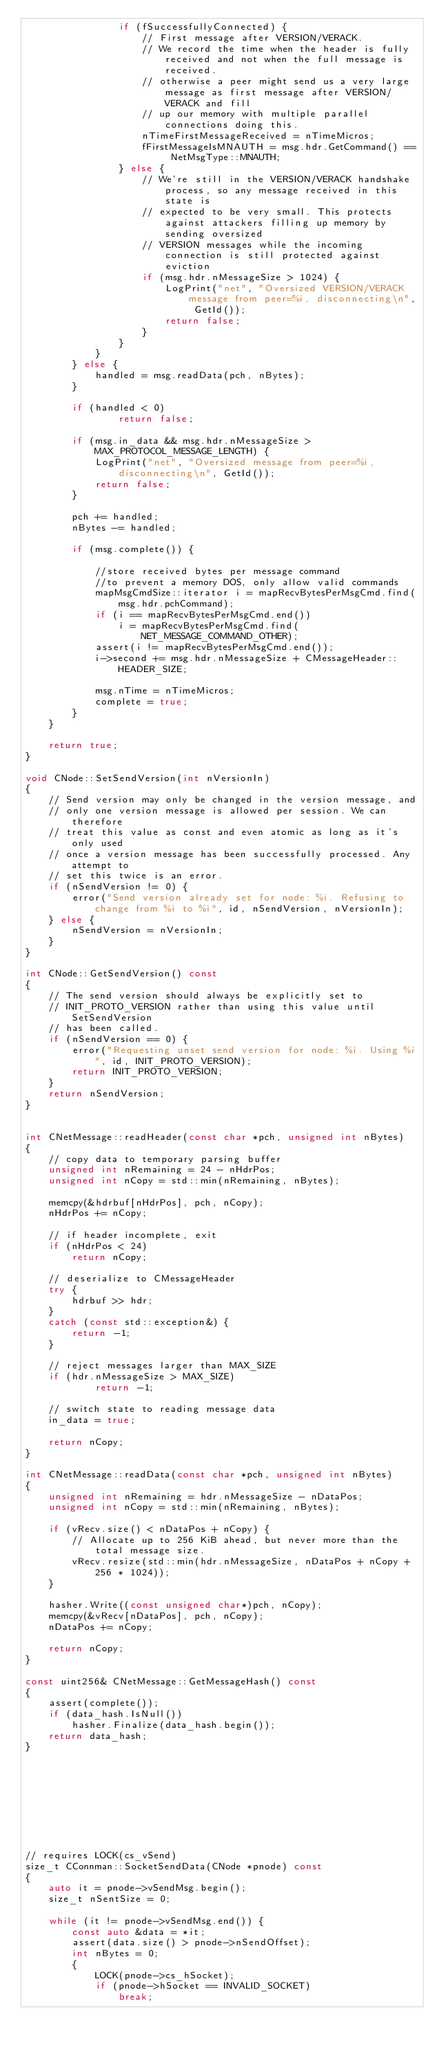Convert code to text. <code><loc_0><loc_0><loc_500><loc_500><_C++_>                if (fSuccessfullyConnected) {
                    // First message after VERSION/VERACK.
                    // We record the time when the header is fully received and not when the full message is received.
                    // otherwise a peer might send us a very large message as first message after VERSION/VERACK and fill
                    // up our memory with multiple parallel connections doing this.
                    nTimeFirstMessageReceived = nTimeMicros;
                    fFirstMessageIsMNAUTH = msg.hdr.GetCommand() == NetMsgType::MNAUTH;
                } else {
                    // We're still in the VERSION/VERACK handshake process, so any message received in this state is
                    // expected to be very small. This protects against attackers filling up memory by sending oversized
                    // VERSION messages while the incoming connection is still protected against eviction
                    if (msg.hdr.nMessageSize > 1024) {
                        LogPrint("net", "Oversized VERSION/VERACK message from peer=%i, disconnecting\n", GetId());
                        return false;
                    }
                }
            }
        } else {
            handled = msg.readData(pch, nBytes);
        }

        if (handled < 0)
                return false;

        if (msg.in_data && msg.hdr.nMessageSize > MAX_PROTOCOL_MESSAGE_LENGTH) {
            LogPrint("net", "Oversized message from peer=%i, disconnecting\n", GetId());
            return false;
        }

        pch += handled;
        nBytes -= handled;

        if (msg.complete()) {

            //store received bytes per message command
            //to prevent a memory DOS, only allow valid commands
            mapMsgCmdSize::iterator i = mapRecvBytesPerMsgCmd.find(msg.hdr.pchCommand);
            if (i == mapRecvBytesPerMsgCmd.end())
                i = mapRecvBytesPerMsgCmd.find(NET_MESSAGE_COMMAND_OTHER);
            assert(i != mapRecvBytesPerMsgCmd.end());
            i->second += msg.hdr.nMessageSize + CMessageHeader::HEADER_SIZE;

            msg.nTime = nTimeMicros;
            complete = true;
        }
    }

    return true;
}

void CNode::SetSendVersion(int nVersionIn)
{
    // Send version may only be changed in the version message, and
    // only one version message is allowed per session. We can therefore
    // treat this value as const and even atomic as long as it's only used
    // once a version message has been successfully processed. Any attempt to
    // set this twice is an error.
    if (nSendVersion != 0) {
        error("Send version already set for node: %i. Refusing to change from %i to %i", id, nSendVersion, nVersionIn);
    } else {
        nSendVersion = nVersionIn;
    }
}

int CNode::GetSendVersion() const
{
    // The send version should always be explicitly set to
    // INIT_PROTO_VERSION rather than using this value until SetSendVersion
    // has been called.
    if (nSendVersion == 0) {
        error("Requesting unset send version for node: %i. Using %i", id, INIT_PROTO_VERSION);
        return INIT_PROTO_VERSION;
    }
    return nSendVersion;
}


int CNetMessage::readHeader(const char *pch, unsigned int nBytes)
{
    // copy data to temporary parsing buffer
    unsigned int nRemaining = 24 - nHdrPos;
    unsigned int nCopy = std::min(nRemaining, nBytes);

    memcpy(&hdrbuf[nHdrPos], pch, nCopy);
    nHdrPos += nCopy;

    // if header incomplete, exit
    if (nHdrPos < 24)
        return nCopy;

    // deserialize to CMessageHeader
    try {
        hdrbuf >> hdr;
    }
    catch (const std::exception&) {
        return -1;
    }

    // reject messages larger than MAX_SIZE
    if (hdr.nMessageSize > MAX_SIZE)
            return -1;

    // switch state to reading message data
    in_data = true;

    return nCopy;
}

int CNetMessage::readData(const char *pch, unsigned int nBytes)
{
    unsigned int nRemaining = hdr.nMessageSize - nDataPos;
    unsigned int nCopy = std::min(nRemaining, nBytes);

    if (vRecv.size() < nDataPos + nCopy) {
        // Allocate up to 256 KiB ahead, but never more than the total message size.
        vRecv.resize(std::min(hdr.nMessageSize, nDataPos + nCopy + 256 * 1024));
    }

    hasher.Write((const unsigned char*)pch, nCopy);
    memcpy(&vRecv[nDataPos], pch, nCopy);
    nDataPos += nCopy;

    return nCopy;
}

const uint256& CNetMessage::GetMessageHash() const
{
    assert(complete());
    if (data_hash.IsNull())
        hasher.Finalize(data_hash.begin());
    return data_hash;
}









// requires LOCK(cs_vSend)
size_t CConnman::SocketSendData(CNode *pnode) const
{
    auto it = pnode->vSendMsg.begin();
    size_t nSentSize = 0;

    while (it != pnode->vSendMsg.end()) {
        const auto &data = *it;
        assert(data.size() > pnode->nSendOffset);
        int nBytes = 0;
        {
            LOCK(pnode->cs_hSocket);
            if (pnode->hSocket == INVALID_SOCKET)
                break;</code> 